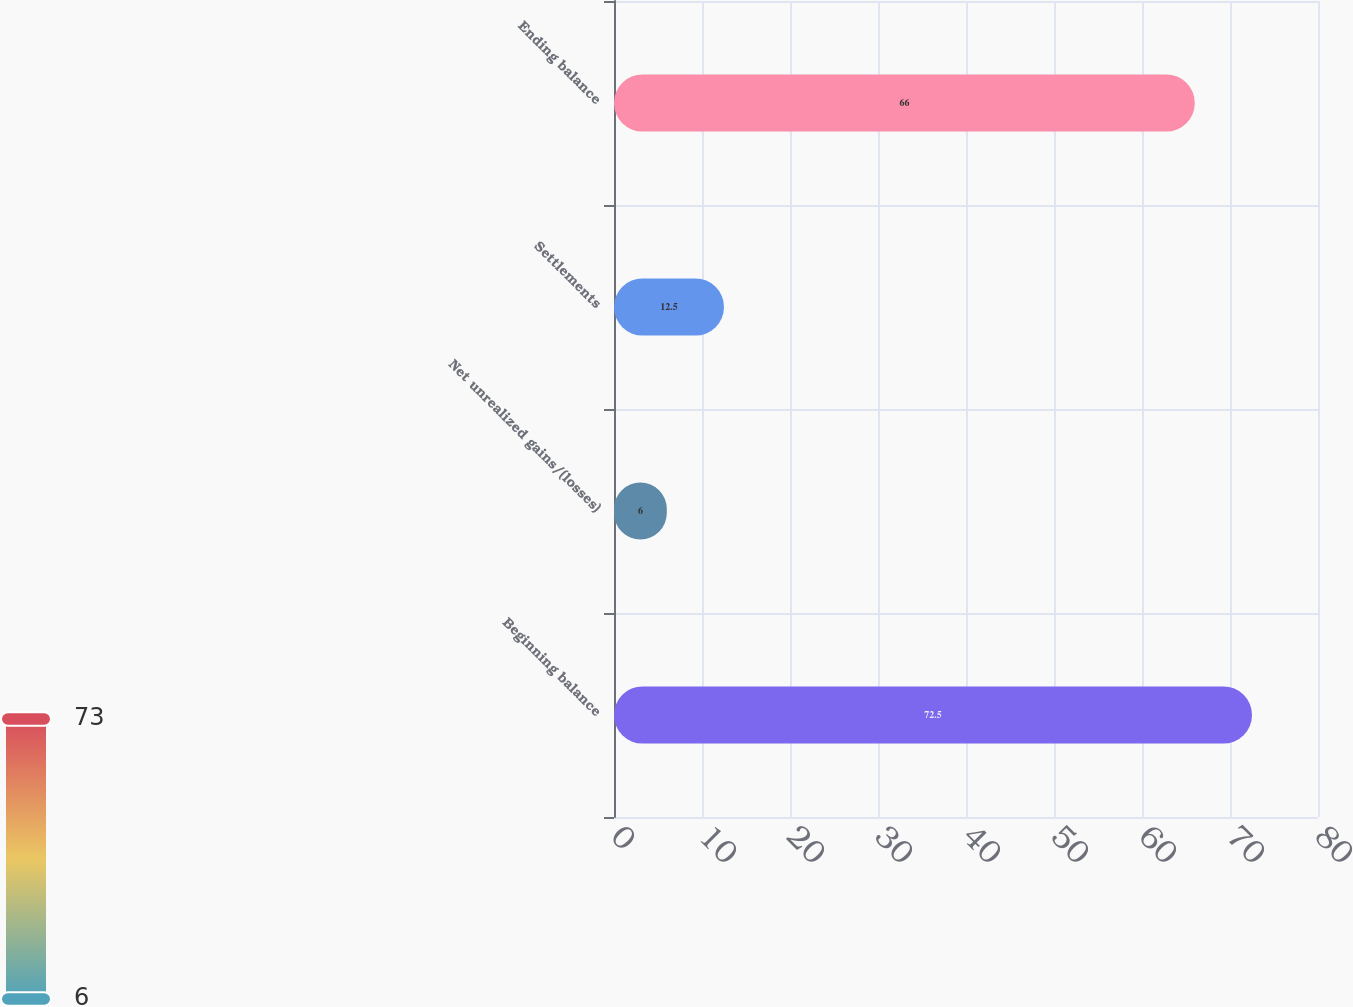Convert chart to OTSL. <chart><loc_0><loc_0><loc_500><loc_500><bar_chart><fcel>Beginning balance<fcel>Net unrealized gains/(losses)<fcel>Settlements<fcel>Ending balance<nl><fcel>72.5<fcel>6<fcel>12.5<fcel>66<nl></chart> 